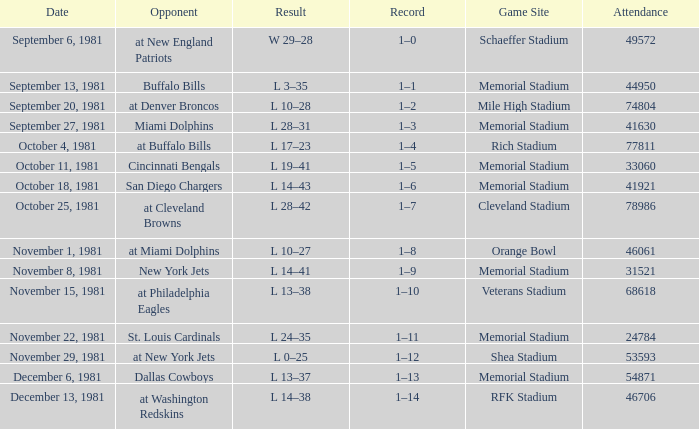In week 2, what is the record's status? 1–1. 